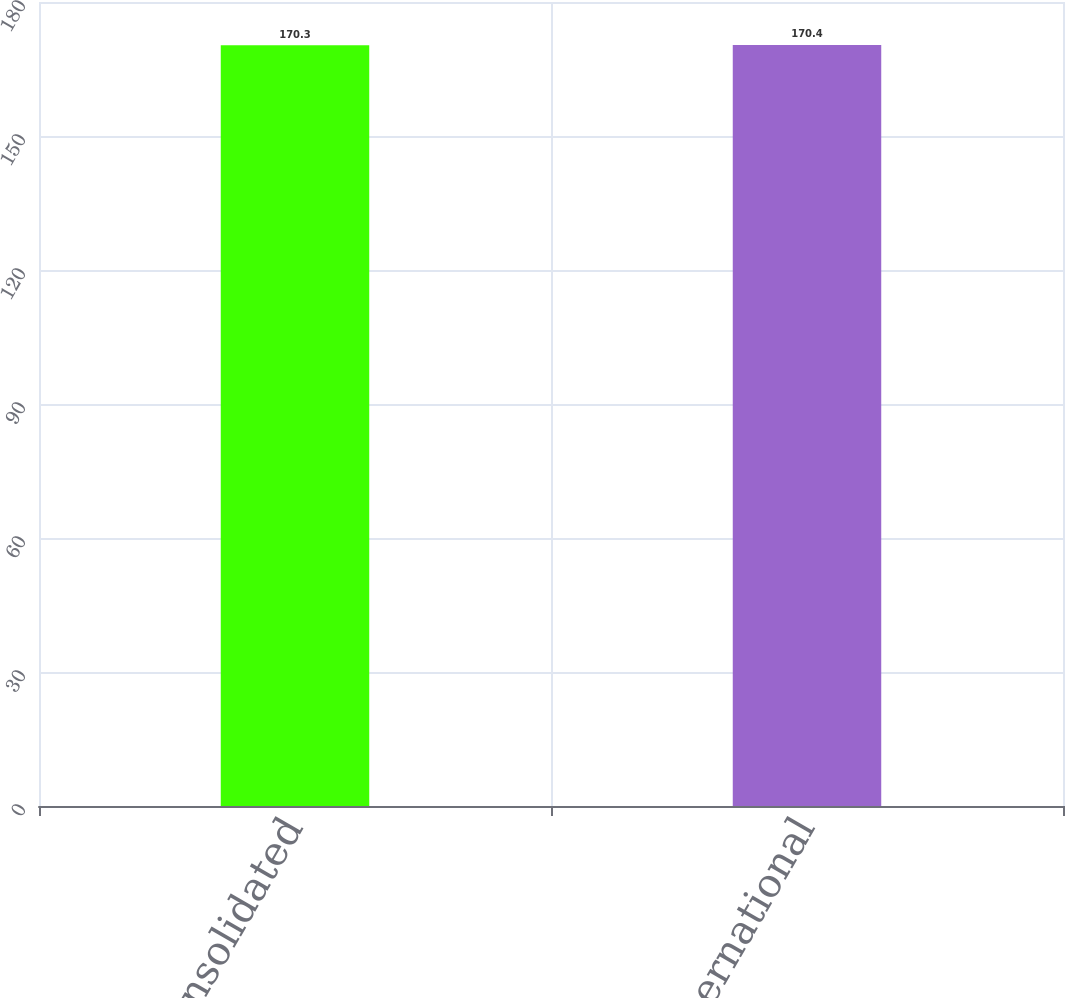Convert chart to OTSL. <chart><loc_0><loc_0><loc_500><loc_500><bar_chart><fcel>Consolidated<fcel>International<nl><fcel>170.3<fcel>170.4<nl></chart> 